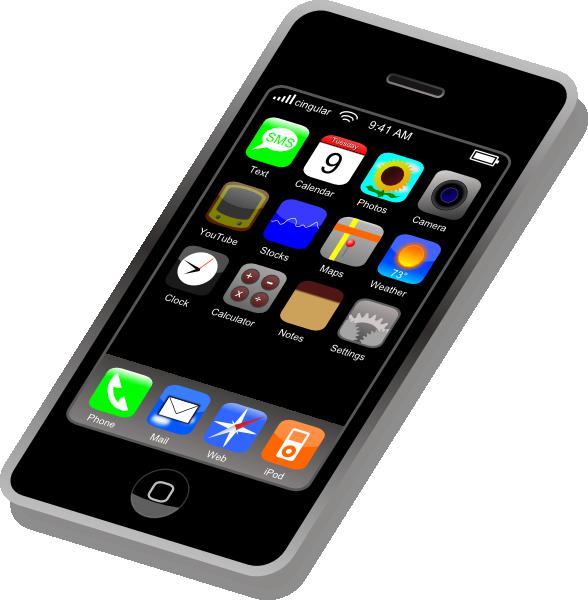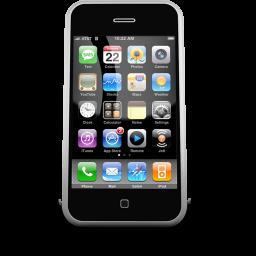The first image is the image on the left, the second image is the image on the right. Evaluate the accuracy of this statement regarding the images: "One of the images shows a cell phone docked on a landline phone base.". Is it true? Answer yes or no. No. The first image is the image on the left, the second image is the image on the right. For the images displayed, is the sentence "There are exactly two phones in the right image." factually correct? Answer yes or no. No. 